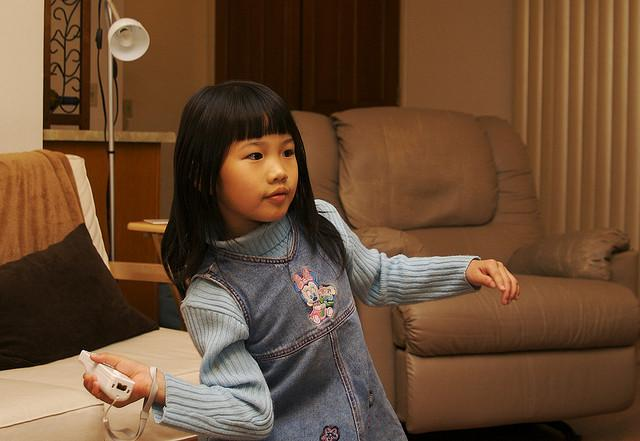Who created the character on the girls dress?

Choices:
A) walt disney
B) dreamworks
C) pixar
D) warner brothers walt disney 